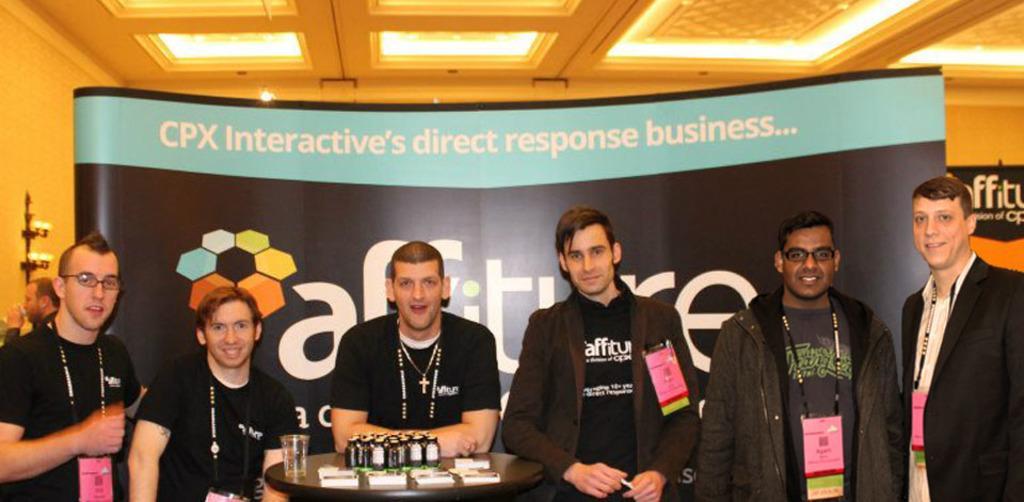How would you summarize this image in a sentence or two? In the center of the image there are people standing. There is a table on which there are objects. In the background of the image there is a banner. At the top of the image there is a ceiling with lights. 